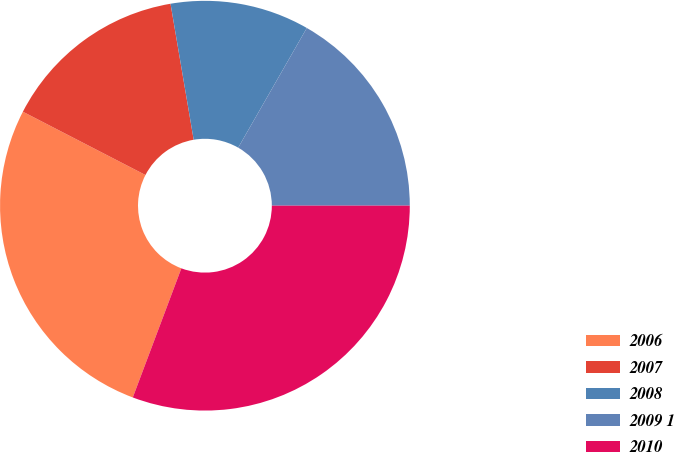Convert chart. <chart><loc_0><loc_0><loc_500><loc_500><pie_chart><fcel>2006<fcel>2007<fcel>2008<fcel>2009 1<fcel>2010<nl><fcel>26.86%<fcel>14.73%<fcel>10.97%<fcel>16.71%<fcel>30.73%<nl></chart> 